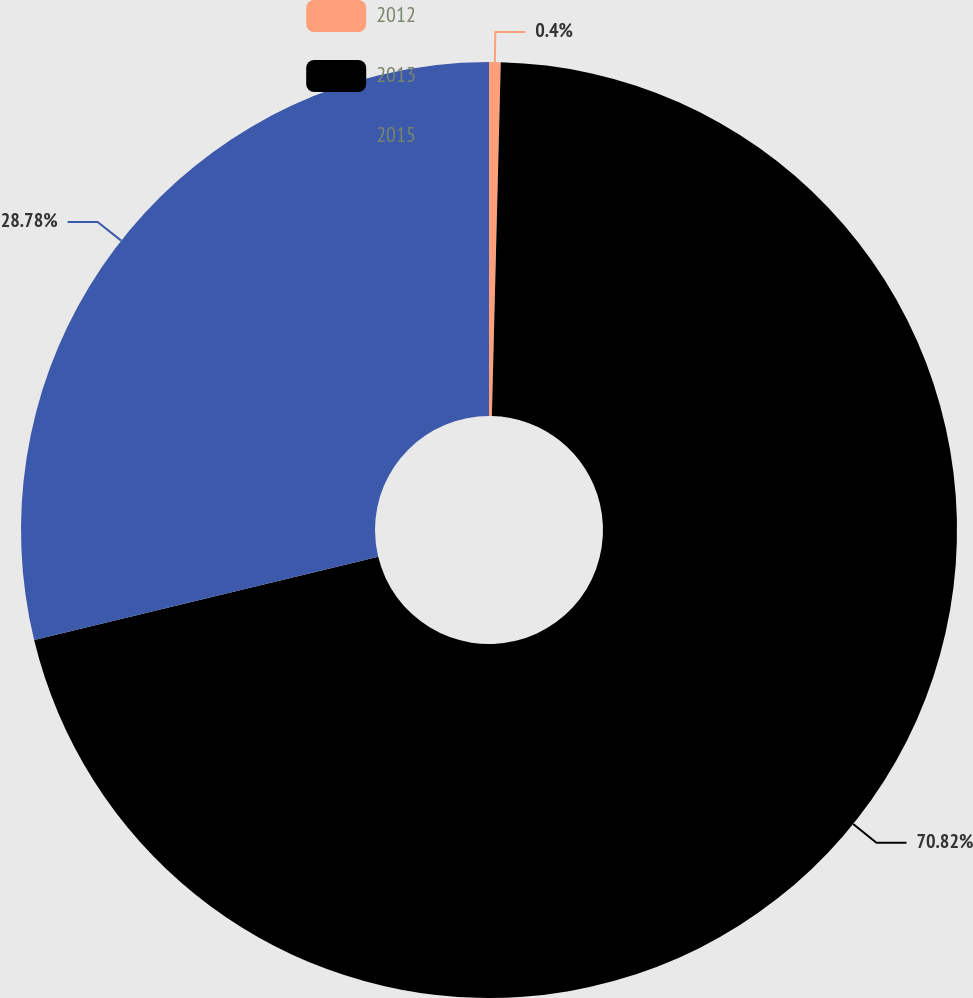Convert chart. <chart><loc_0><loc_0><loc_500><loc_500><pie_chart><fcel>2012<fcel>2013<fcel>2015<nl><fcel>0.4%<fcel>70.82%<fcel>28.78%<nl></chart> 